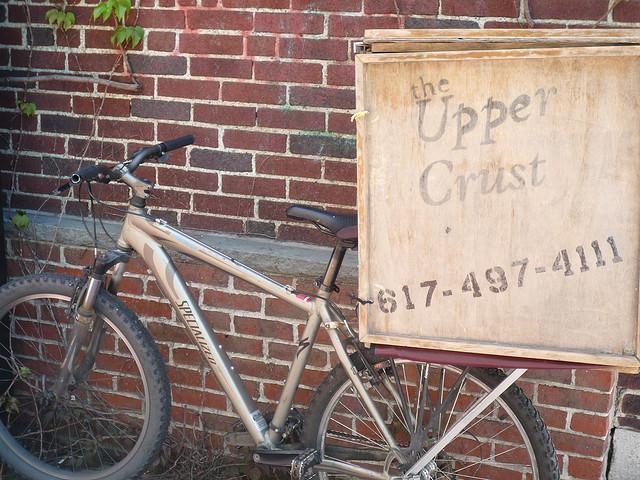Is this a professional quality sign?
Keep it brief. No. What is the phone number shown?
Give a very brief answer. 617-497-4111. What vehicle is shown?
Answer briefly. Bicycle. 